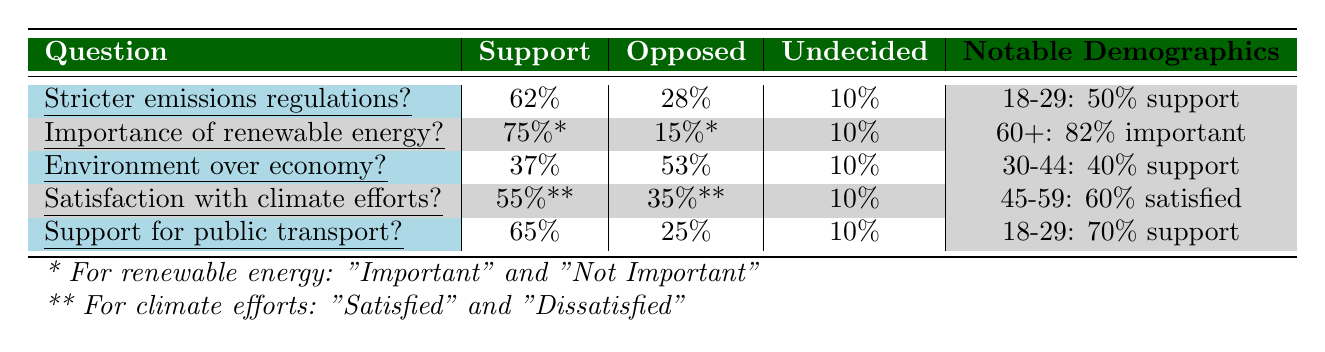What percentage of respondents support stricter emissions regulations? The table indicates that 62% of respondents support stricter regulations on emissions from industries.
Answer: 62% What percentage of respondents opposed prioritizing environmental policies over economic growth? The table shows that 53% of respondents opposed the idea of prioritizing environmental policies over economic growth.
Answer: 53% Which age group has the highest percentage supporting renewable energy investments? According to the table, the age group 60+ has the highest percentage (82%) indicating that renewable energy investment is important.
Answer: 60+ What is the difference between the support for public transport investments and opposition to it? For public transport investments, 65% support and 25% oppose. The difference is 65% - 25% = 40%.
Answer: 40% Are more respondents satisfied or dissatisfied with the current government efforts towards climate change? The table states that 55% are satisfied and 35% are dissatisfied. Thus, more respondents are satisfied.
Answer: Yes What is the average support percentage across all five questions listed? The support percentages are 62%, 75%, 37%, 55%, and 65%. The average is (62 + 75 + 37 + 55 + 65) / 5 = 58.8%.
Answer: 58.8% Is it true that a majority of conservatives support stricter emissions regulations? Since 62% support stricter emissions regulations, which is more than half, it is true.
Answer: Yes Which question had the lowest support percentage? The question regarding prioritizing environmental policies over economic growth had the lowest support at 37%.
Answer: 37% What percentage of respondents are undecided about public transport investments? The table shows that 10% of respondents are undecided about supporting public transport investments to reduce carbon footprint.
Answer: 10% What can be inferred about the sentiment towards climate change government efforts for the 45-59 age group? The table shows that 60% of the 45-59 age group is satisfied with the current government efforts towards climate change, which indicates a positive sentiment.
Answer: Positive sentiment 